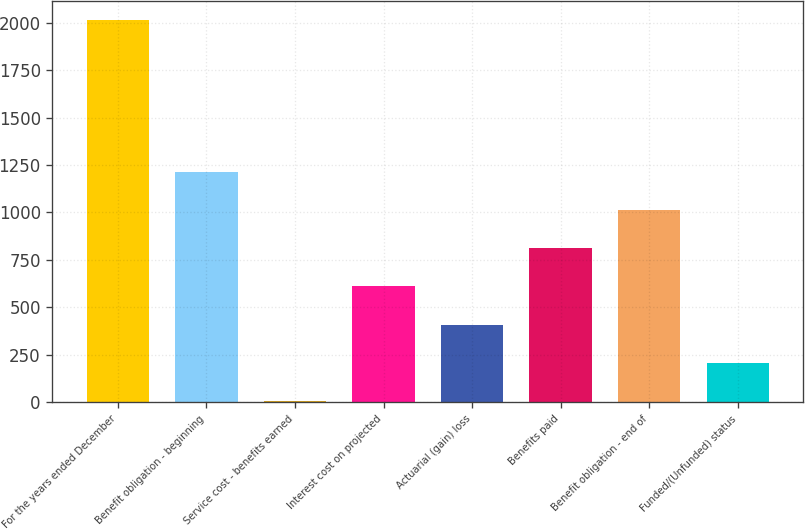<chart> <loc_0><loc_0><loc_500><loc_500><bar_chart><fcel>For the years ended December<fcel>Benefit obligation - beginning<fcel>Service cost - benefits earned<fcel>Interest cost on projected<fcel>Actuarial (gain) loss<fcel>Benefits paid<fcel>Benefit obligation - end of<fcel>Funded/(Unfunded) status<nl><fcel>2017<fcel>1212.6<fcel>6<fcel>609.3<fcel>408.2<fcel>810.4<fcel>1011.5<fcel>207.1<nl></chart> 